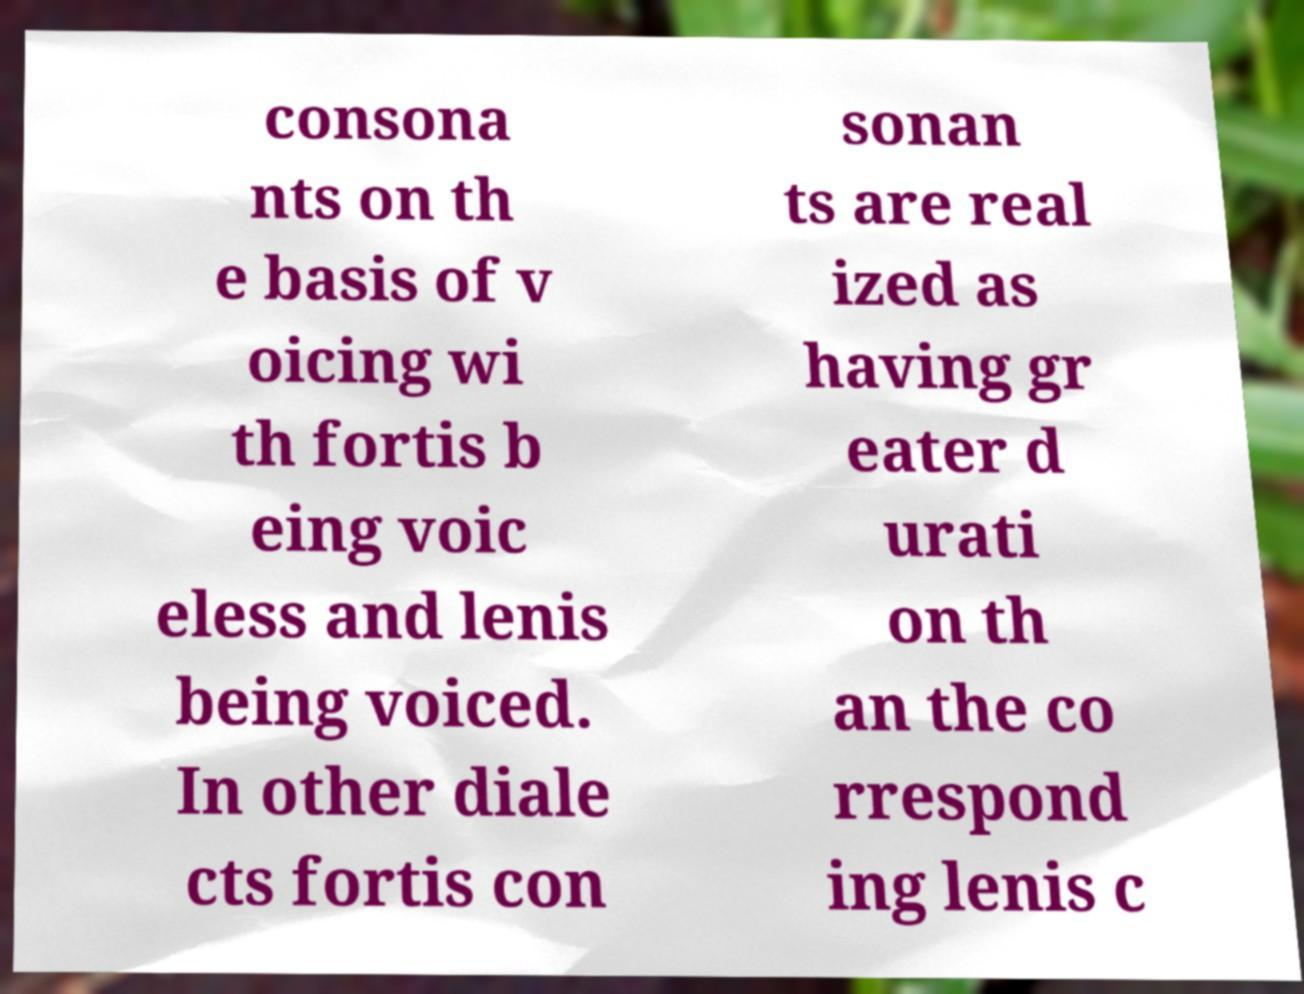Could you assist in decoding the text presented in this image and type it out clearly? consona nts on th e basis of v oicing wi th fortis b eing voic eless and lenis being voiced. In other diale cts fortis con sonan ts are real ized as having gr eater d urati on th an the co rrespond ing lenis c 